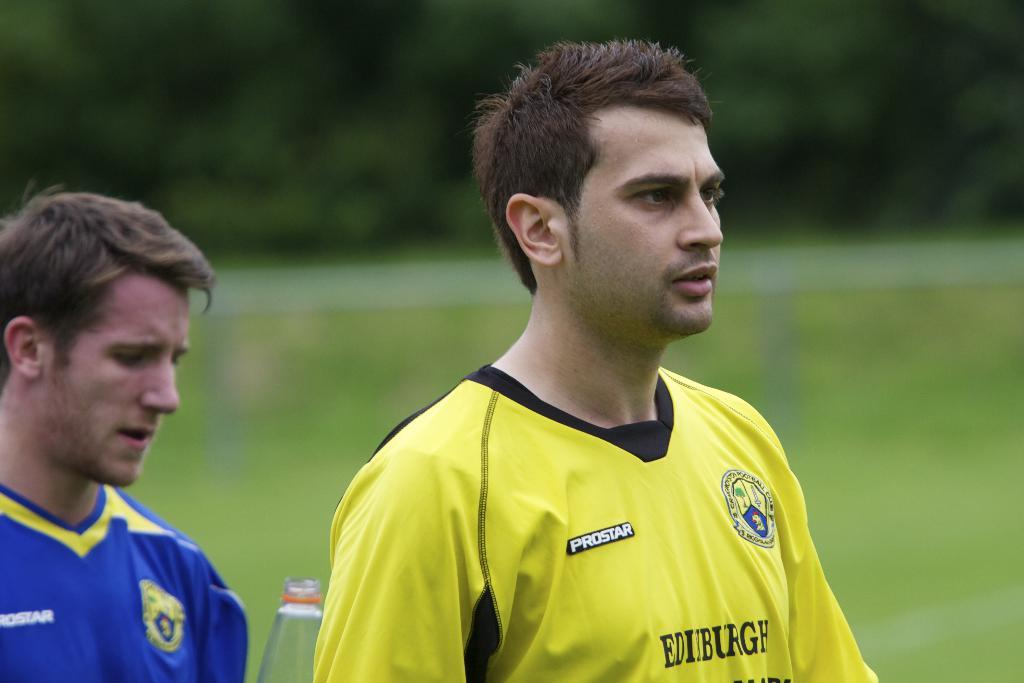<image>
Relay a brief, clear account of the picture shown. Man wearing a yellow jersey with the word Edinburgh on it. 